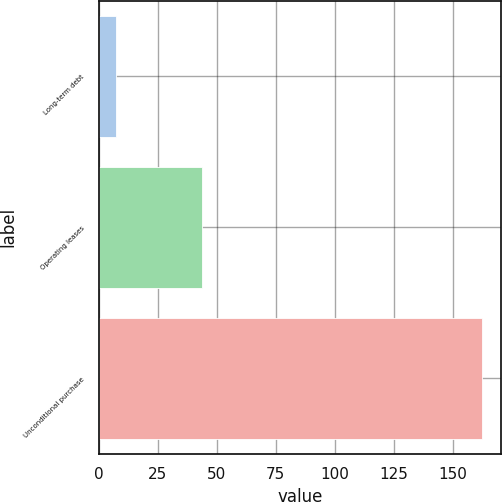<chart> <loc_0><loc_0><loc_500><loc_500><bar_chart><fcel>Long-term debt<fcel>Operating leases<fcel>Unconditional purchase<nl><fcel>7.3<fcel>43.7<fcel>162.5<nl></chart> 